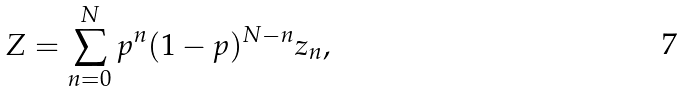<formula> <loc_0><loc_0><loc_500><loc_500>Z = \sum _ { n = 0 } ^ { N } p ^ { n } ( 1 - p ) ^ { N - n } z _ { n } ,</formula> 